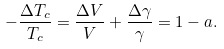<formula> <loc_0><loc_0><loc_500><loc_500>- \frac { \Delta T _ { c } } { T _ { c } } = \frac { \Delta V } { V } + \frac { \Delta \gamma } { \gamma } = 1 - a .</formula> 